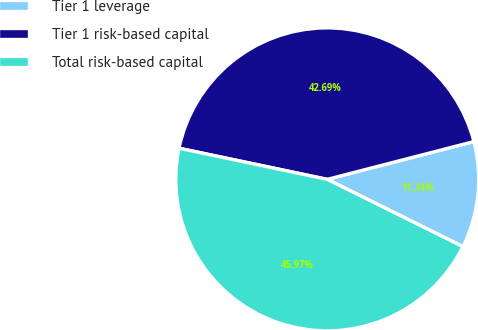<chart> <loc_0><loc_0><loc_500><loc_500><pie_chart><fcel>Tier 1 leverage<fcel>Tier 1 risk-based capital<fcel>Total risk-based capital<nl><fcel>11.34%<fcel>42.69%<fcel>45.97%<nl></chart> 